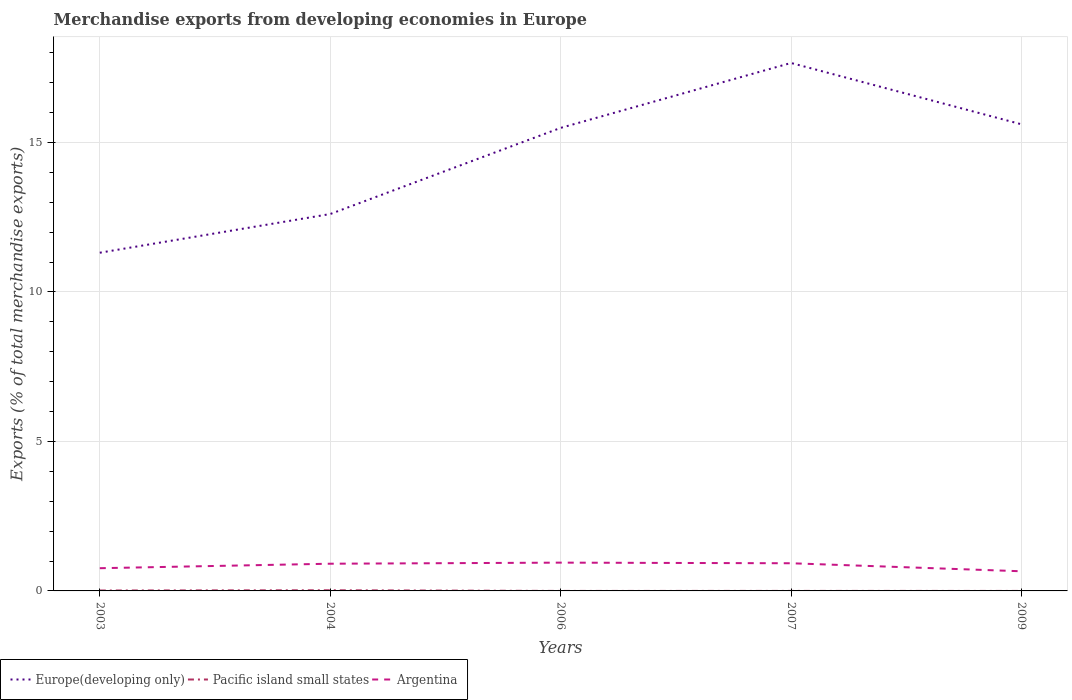How many different coloured lines are there?
Keep it short and to the point. 3. Does the line corresponding to Argentina intersect with the line corresponding to Pacific island small states?
Your answer should be compact. No. Is the number of lines equal to the number of legend labels?
Your answer should be compact. Yes. Across all years, what is the maximum percentage of total merchandise exports in Argentina?
Your answer should be compact. 0.66. In which year was the percentage of total merchandise exports in Pacific island small states maximum?
Your response must be concise. 2006. What is the total percentage of total merchandise exports in Europe(developing only) in the graph?
Offer a very short reply. -6.35. What is the difference between the highest and the second highest percentage of total merchandise exports in Europe(developing only)?
Give a very brief answer. 6.35. Does the graph contain grids?
Ensure brevity in your answer.  Yes. Where does the legend appear in the graph?
Offer a terse response. Bottom left. How many legend labels are there?
Provide a succinct answer. 3. What is the title of the graph?
Keep it short and to the point. Merchandise exports from developing economies in Europe. What is the label or title of the X-axis?
Offer a terse response. Years. What is the label or title of the Y-axis?
Provide a succinct answer. Exports (% of total merchandise exports). What is the Exports (% of total merchandise exports) of Europe(developing only) in 2003?
Provide a succinct answer. 11.31. What is the Exports (% of total merchandise exports) in Pacific island small states in 2003?
Provide a succinct answer. 0.01. What is the Exports (% of total merchandise exports) in Argentina in 2003?
Your answer should be compact. 0.76. What is the Exports (% of total merchandise exports) in Europe(developing only) in 2004?
Provide a short and direct response. 12.61. What is the Exports (% of total merchandise exports) of Pacific island small states in 2004?
Make the answer very short. 0.02. What is the Exports (% of total merchandise exports) in Argentina in 2004?
Offer a terse response. 0.91. What is the Exports (% of total merchandise exports) in Europe(developing only) in 2006?
Offer a terse response. 15.49. What is the Exports (% of total merchandise exports) of Pacific island small states in 2006?
Make the answer very short. 1.16415963627046e-5. What is the Exports (% of total merchandise exports) in Argentina in 2006?
Your response must be concise. 0.95. What is the Exports (% of total merchandise exports) in Europe(developing only) in 2007?
Keep it short and to the point. 17.66. What is the Exports (% of total merchandise exports) in Pacific island small states in 2007?
Offer a very short reply. 0. What is the Exports (% of total merchandise exports) of Argentina in 2007?
Ensure brevity in your answer.  0.93. What is the Exports (% of total merchandise exports) of Europe(developing only) in 2009?
Your answer should be very brief. 15.61. What is the Exports (% of total merchandise exports) of Pacific island small states in 2009?
Offer a very short reply. 0. What is the Exports (% of total merchandise exports) in Argentina in 2009?
Offer a terse response. 0.66. Across all years, what is the maximum Exports (% of total merchandise exports) of Europe(developing only)?
Keep it short and to the point. 17.66. Across all years, what is the maximum Exports (% of total merchandise exports) of Pacific island small states?
Give a very brief answer. 0.02. Across all years, what is the maximum Exports (% of total merchandise exports) in Argentina?
Provide a succinct answer. 0.95. Across all years, what is the minimum Exports (% of total merchandise exports) of Europe(developing only)?
Your answer should be very brief. 11.31. Across all years, what is the minimum Exports (% of total merchandise exports) in Pacific island small states?
Your answer should be compact. 1.16415963627046e-5. Across all years, what is the minimum Exports (% of total merchandise exports) of Argentina?
Provide a succinct answer. 0.66. What is the total Exports (% of total merchandise exports) of Europe(developing only) in the graph?
Keep it short and to the point. 72.68. What is the total Exports (% of total merchandise exports) in Pacific island small states in the graph?
Ensure brevity in your answer.  0.04. What is the total Exports (% of total merchandise exports) of Argentina in the graph?
Offer a very short reply. 4.2. What is the difference between the Exports (% of total merchandise exports) in Europe(developing only) in 2003 and that in 2004?
Ensure brevity in your answer.  -1.29. What is the difference between the Exports (% of total merchandise exports) of Pacific island small states in 2003 and that in 2004?
Give a very brief answer. -0.01. What is the difference between the Exports (% of total merchandise exports) in Argentina in 2003 and that in 2004?
Provide a succinct answer. -0.15. What is the difference between the Exports (% of total merchandise exports) of Europe(developing only) in 2003 and that in 2006?
Offer a very short reply. -4.18. What is the difference between the Exports (% of total merchandise exports) in Pacific island small states in 2003 and that in 2006?
Offer a very short reply. 0.01. What is the difference between the Exports (% of total merchandise exports) in Argentina in 2003 and that in 2006?
Your response must be concise. -0.19. What is the difference between the Exports (% of total merchandise exports) of Europe(developing only) in 2003 and that in 2007?
Give a very brief answer. -6.35. What is the difference between the Exports (% of total merchandise exports) in Pacific island small states in 2003 and that in 2007?
Make the answer very short. 0.01. What is the difference between the Exports (% of total merchandise exports) of Argentina in 2003 and that in 2007?
Make the answer very short. -0.17. What is the difference between the Exports (% of total merchandise exports) in Europe(developing only) in 2003 and that in 2009?
Offer a very short reply. -4.3. What is the difference between the Exports (% of total merchandise exports) of Pacific island small states in 2003 and that in 2009?
Give a very brief answer. 0.01. What is the difference between the Exports (% of total merchandise exports) of Argentina in 2003 and that in 2009?
Provide a succinct answer. 0.1. What is the difference between the Exports (% of total merchandise exports) of Europe(developing only) in 2004 and that in 2006?
Keep it short and to the point. -2.88. What is the difference between the Exports (% of total merchandise exports) of Pacific island small states in 2004 and that in 2006?
Ensure brevity in your answer.  0.02. What is the difference between the Exports (% of total merchandise exports) in Argentina in 2004 and that in 2006?
Provide a succinct answer. -0.04. What is the difference between the Exports (% of total merchandise exports) in Europe(developing only) in 2004 and that in 2007?
Your answer should be very brief. -5.05. What is the difference between the Exports (% of total merchandise exports) of Pacific island small states in 2004 and that in 2007?
Your answer should be very brief. 0.02. What is the difference between the Exports (% of total merchandise exports) of Argentina in 2004 and that in 2007?
Offer a very short reply. -0.02. What is the difference between the Exports (% of total merchandise exports) of Europe(developing only) in 2004 and that in 2009?
Provide a succinct answer. -3. What is the difference between the Exports (% of total merchandise exports) in Pacific island small states in 2004 and that in 2009?
Keep it short and to the point. 0.02. What is the difference between the Exports (% of total merchandise exports) of Argentina in 2004 and that in 2009?
Your answer should be compact. 0.25. What is the difference between the Exports (% of total merchandise exports) of Europe(developing only) in 2006 and that in 2007?
Provide a succinct answer. -2.17. What is the difference between the Exports (% of total merchandise exports) in Pacific island small states in 2006 and that in 2007?
Your answer should be very brief. -0. What is the difference between the Exports (% of total merchandise exports) of Argentina in 2006 and that in 2007?
Your answer should be very brief. 0.02. What is the difference between the Exports (% of total merchandise exports) of Europe(developing only) in 2006 and that in 2009?
Provide a succinct answer. -0.12. What is the difference between the Exports (% of total merchandise exports) in Pacific island small states in 2006 and that in 2009?
Make the answer very short. -0. What is the difference between the Exports (% of total merchandise exports) of Argentina in 2006 and that in 2009?
Keep it short and to the point. 0.29. What is the difference between the Exports (% of total merchandise exports) in Europe(developing only) in 2007 and that in 2009?
Offer a very short reply. 2.05. What is the difference between the Exports (% of total merchandise exports) of Argentina in 2007 and that in 2009?
Provide a short and direct response. 0.27. What is the difference between the Exports (% of total merchandise exports) in Europe(developing only) in 2003 and the Exports (% of total merchandise exports) in Pacific island small states in 2004?
Keep it short and to the point. 11.29. What is the difference between the Exports (% of total merchandise exports) in Europe(developing only) in 2003 and the Exports (% of total merchandise exports) in Argentina in 2004?
Your answer should be very brief. 10.4. What is the difference between the Exports (% of total merchandise exports) of Pacific island small states in 2003 and the Exports (% of total merchandise exports) of Argentina in 2004?
Provide a short and direct response. -0.9. What is the difference between the Exports (% of total merchandise exports) of Europe(developing only) in 2003 and the Exports (% of total merchandise exports) of Pacific island small states in 2006?
Provide a succinct answer. 11.31. What is the difference between the Exports (% of total merchandise exports) in Europe(developing only) in 2003 and the Exports (% of total merchandise exports) in Argentina in 2006?
Your response must be concise. 10.37. What is the difference between the Exports (% of total merchandise exports) in Pacific island small states in 2003 and the Exports (% of total merchandise exports) in Argentina in 2006?
Provide a short and direct response. -0.93. What is the difference between the Exports (% of total merchandise exports) in Europe(developing only) in 2003 and the Exports (% of total merchandise exports) in Pacific island small states in 2007?
Offer a very short reply. 11.31. What is the difference between the Exports (% of total merchandise exports) in Europe(developing only) in 2003 and the Exports (% of total merchandise exports) in Argentina in 2007?
Offer a very short reply. 10.39. What is the difference between the Exports (% of total merchandise exports) in Pacific island small states in 2003 and the Exports (% of total merchandise exports) in Argentina in 2007?
Ensure brevity in your answer.  -0.91. What is the difference between the Exports (% of total merchandise exports) of Europe(developing only) in 2003 and the Exports (% of total merchandise exports) of Pacific island small states in 2009?
Your response must be concise. 11.31. What is the difference between the Exports (% of total merchandise exports) in Europe(developing only) in 2003 and the Exports (% of total merchandise exports) in Argentina in 2009?
Provide a short and direct response. 10.66. What is the difference between the Exports (% of total merchandise exports) in Pacific island small states in 2003 and the Exports (% of total merchandise exports) in Argentina in 2009?
Offer a very short reply. -0.64. What is the difference between the Exports (% of total merchandise exports) in Europe(developing only) in 2004 and the Exports (% of total merchandise exports) in Pacific island small states in 2006?
Offer a terse response. 12.61. What is the difference between the Exports (% of total merchandise exports) in Europe(developing only) in 2004 and the Exports (% of total merchandise exports) in Argentina in 2006?
Offer a very short reply. 11.66. What is the difference between the Exports (% of total merchandise exports) of Pacific island small states in 2004 and the Exports (% of total merchandise exports) of Argentina in 2006?
Your answer should be compact. -0.92. What is the difference between the Exports (% of total merchandise exports) of Europe(developing only) in 2004 and the Exports (% of total merchandise exports) of Pacific island small states in 2007?
Offer a very short reply. 12.61. What is the difference between the Exports (% of total merchandise exports) in Europe(developing only) in 2004 and the Exports (% of total merchandise exports) in Argentina in 2007?
Your answer should be compact. 11.68. What is the difference between the Exports (% of total merchandise exports) in Pacific island small states in 2004 and the Exports (% of total merchandise exports) in Argentina in 2007?
Keep it short and to the point. -0.9. What is the difference between the Exports (% of total merchandise exports) of Europe(developing only) in 2004 and the Exports (% of total merchandise exports) of Pacific island small states in 2009?
Give a very brief answer. 12.61. What is the difference between the Exports (% of total merchandise exports) in Europe(developing only) in 2004 and the Exports (% of total merchandise exports) in Argentina in 2009?
Give a very brief answer. 11.95. What is the difference between the Exports (% of total merchandise exports) in Pacific island small states in 2004 and the Exports (% of total merchandise exports) in Argentina in 2009?
Give a very brief answer. -0.64. What is the difference between the Exports (% of total merchandise exports) in Europe(developing only) in 2006 and the Exports (% of total merchandise exports) in Pacific island small states in 2007?
Your answer should be compact. 15.49. What is the difference between the Exports (% of total merchandise exports) in Europe(developing only) in 2006 and the Exports (% of total merchandise exports) in Argentina in 2007?
Provide a succinct answer. 14.56. What is the difference between the Exports (% of total merchandise exports) of Pacific island small states in 2006 and the Exports (% of total merchandise exports) of Argentina in 2007?
Your answer should be very brief. -0.93. What is the difference between the Exports (% of total merchandise exports) in Europe(developing only) in 2006 and the Exports (% of total merchandise exports) in Pacific island small states in 2009?
Offer a terse response. 15.49. What is the difference between the Exports (% of total merchandise exports) of Europe(developing only) in 2006 and the Exports (% of total merchandise exports) of Argentina in 2009?
Provide a succinct answer. 14.83. What is the difference between the Exports (% of total merchandise exports) of Pacific island small states in 2006 and the Exports (% of total merchandise exports) of Argentina in 2009?
Your answer should be compact. -0.66. What is the difference between the Exports (% of total merchandise exports) of Europe(developing only) in 2007 and the Exports (% of total merchandise exports) of Pacific island small states in 2009?
Give a very brief answer. 17.66. What is the difference between the Exports (% of total merchandise exports) of Europe(developing only) in 2007 and the Exports (% of total merchandise exports) of Argentina in 2009?
Keep it short and to the point. 17. What is the difference between the Exports (% of total merchandise exports) of Pacific island small states in 2007 and the Exports (% of total merchandise exports) of Argentina in 2009?
Offer a terse response. -0.66. What is the average Exports (% of total merchandise exports) of Europe(developing only) per year?
Provide a short and direct response. 14.54. What is the average Exports (% of total merchandise exports) in Pacific island small states per year?
Offer a very short reply. 0.01. What is the average Exports (% of total merchandise exports) of Argentina per year?
Give a very brief answer. 0.84. In the year 2003, what is the difference between the Exports (% of total merchandise exports) of Europe(developing only) and Exports (% of total merchandise exports) of Pacific island small states?
Your response must be concise. 11.3. In the year 2003, what is the difference between the Exports (% of total merchandise exports) in Europe(developing only) and Exports (% of total merchandise exports) in Argentina?
Provide a short and direct response. 10.55. In the year 2003, what is the difference between the Exports (% of total merchandise exports) of Pacific island small states and Exports (% of total merchandise exports) of Argentina?
Provide a short and direct response. -0.75. In the year 2004, what is the difference between the Exports (% of total merchandise exports) in Europe(developing only) and Exports (% of total merchandise exports) in Pacific island small states?
Provide a succinct answer. 12.59. In the year 2004, what is the difference between the Exports (% of total merchandise exports) of Europe(developing only) and Exports (% of total merchandise exports) of Argentina?
Keep it short and to the point. 11.7. In the year 2004, what is the difference between the Exports (% of total merchandise exports) of Pacific island small states and Exports (% of total merchandise exports) of Argentina?
Your response must be concise. -0.89. In the year 2006, what is the difference between the Exports (% of total merchandise exports) of Europe(developing only) and Exports (% of total merchandise exports) of Pacific island small states?
Provide a succinct answer. 15.49. In the year 2006, what is the difference between the Exports (% of total merchandise exports) in Europe(developing only) and Exports (% of total merchandise exports) in Argentina?
Your response must be concise. 14.54. In the year 2006, what is the difference between the Exports (% of total merchandise exports) of Pacific island small states and Exports (% of total merchandise exports) of Argentina?
Keep it short and to the point. -0.95. In the year 2007, what is the difference between the Exports (% of total merchandise exports) in Europe(developing only) and Exports (% of total merchandise exports) in Pacific island small states?
Your answer should be very brief. 17.66. In the year 2007, what is the difference between the Exports (% of total merchandise exports) of Europe(developing only) and Exports (% of total merchandise exports) of Argentina?
Your response must be concise. 16.74. In the year 2007, what is the difference between the Exports (% of total merchandise exports) in Pacific island small states and Exports (% of total merchandise exports) in Argentina?
Your answer should be very brief. -0.93. In the year 2009, what is the difference between the Exports (% of total merchandise exports) of Europe(developing only) and Exports (% of total merchandise exports) of Pacific island small states?
Make the answer very short. 15.61. In the year 2009, what is the difference between the Exports (% of total merchandise exports) of Europe(developing only) and Exports (% of total merchandise exports) of Argentina?
Keep it short and to the point. 14.95. In the year 2009, what is the difference between the Exports (% of total merchandise exports) in Pacific island small states and Exports (% of total merchandise exports) in Argentina?
Your answer should be compact. -0.66. What is the ratio of the Exports (% of total merchandise exports) of Europe(developing only) in 2003 to that in 2004?
Offer a terse response. 0.9. What is the ratio of the Exports (% of total merchandise exports) of Pacific island small states in 2003 to that in 2004?
Offer a terse response. 0.63. What is the ratio of the Exports (% of total merchandise exports) of Argentina in 2003 to that in 2004?
Ensure brevity in your answer.  0.83. What is the ratio of the Exports (% of total merchandise exports) of Europe(developing only) in 2003 to that in 2006?
Your response must be concise. 0.73. What is the ratio of the Exports (% of total merchandise exports) in Pacific island small states in 2003 to that in 2006?
Your answer should be compact. 1193.17. What is the ratio of the Exports (% of total merchandise exports) of Argentina in 2003 to that in 2006?
Your answer should be very brief. 0.8. What is the ratio of the Exports (% of total merchandise exports) of Europe(developing only) in 2003 to that in 2007?
Give a very brief answer. 0.64. What is the ratio of the Exports (% of total merchandise exports) of Pacific island small states in 2003 to that in 2007?
Keep it short and to the point. 31.05. What is the ratio of the Exports (% of total merchandise exports) in Argentina in 2003 to that in 2007?
Provide a short and direct response. 0.82. What is the ratio of the Exports (% of total merchandise exports) of Europe(developing only) in 2003 to that in 2009?
Your answer should be very brief. 0.72. What is the ratio of the Exports (% of total merchandise exports) in Pacific island small states in 2003 to that in 2009?
Provide a short and direct response. 125.81. What is the ratio of the Exports (% of total merchandise exports) of Argentina in 2003 to that in 2009?
Your response must be concise. 1.16. What is the ratio of the Exports (% of total merchandise exports) in Europe(developing only) in 2004 to that in 2006?
Provide a short and direct response. 0.81. What is the ratio of the Exports (% of total merchandise exports) in Pacific island small states in 2004 to that in 2006?
Your response must be concise. 1894.33. What is the ratio of the Exports (% of total merchandise exports) in Argentina in 2004 to that in 2006?
Provide a short and direct response. 0.96. What is the ratio of the Exports (% of total merchandise exports) in Europe(developing only) in 2004 to that in 2007?
Your response must be concise. 0.71. What is the ratio of the Exports (% of total merchandise exports) of Pacific island small states in 2004 to that in 2007?
Provide a succinct answer. 49.3. What is the ratio of the Exports (% of total merchandise exports) of Argentina in 2004 to that in 2007?
Your response must be concise. 0.98. What is the ratio of the Exports (% of total merchandise exports) in Europe(developing only) in 2004 to that in 2009?
Offer a terse response. 0.81. What is the ratio of the Exports (% of total merchandise exports) in Pacific island small states in 2004 to that in 2009?
Provide a short and direct response. 199.74. What is the ratio of the Exports (% of total merchandise exports) in Argentina in 2004 to that in 2009?
Provide a succinct answer. 1.38. What is the ratio of the Exports (% of total merchandise exports) of Europe(developing only) in 2006 to that in 2007?
Keep it short and to the point. 0.88. What is the ratio of the Exports (% of total merchandise exports) of Pacific island small states in 2006 to that in 2007?
Make the answer very short. 0.03. What is the ratio of the Exports (% of total merchandise exports) in Argentina in 2006 to that in 2007?
Ensure brevity in your answer.  1.02. What is the ratio of the Exports (% of total merchandise exports) of Europe(developing only) in 2006 to that in 2009?
Your answer should be very brief. 0.99. What is the ratio of the Exports (% of total merchandise exports) of Pacific island small states in 2006 to that in 2009?
Provide a short and direct response. 0.11. What is the ratio of the Exports (% of total merchandise exports) in Argentina in 2006 to that in 2009?
Offer a terse response. 1.44. What is the ratio of the Exports (% of total merchandise exports) in Europe(developing only) in 2007 to that in 2009?
Make the answer very short. 1.13. What is the ratio of the Exports (% of total merchandise exports) in Pacific island small states in 2007 to that in 2009?
Offer a terse response. 4.05. What is the ratio of the Exports (% of total merchandise exports) in Argentina in 2007 to that in 2009?
Make the answer very short. 1.41. What is the difference between the highest and the second highest Exports (% of total merchandise exports) of Europe(developing only)?
Offer a very short reply. 2.05. What is the difference between the highest and the second highest Exports (% of total merchandise exports) in Pacific island small states?
Offer a terse response. 0.01. What is the difference between the highest and the second highest Exports (% of total merchandise exports) of Argentina?
Ensure brevity in your answer.  0.02. What is the difference between the highest and the lowest Exports (% of total merchandise exports) of Europe(developing only)?
Provide a succinct answer. 6.35. What is the difference between the highest and the lowest Exports (% of total merchandise exports) in Pacific island small states?
Give a very brief answer. 0.02. What is the difference between the highest and the lowest Exports (% of total merchandise exports) in Argentina?
Offer a very short reply. 0.29. 